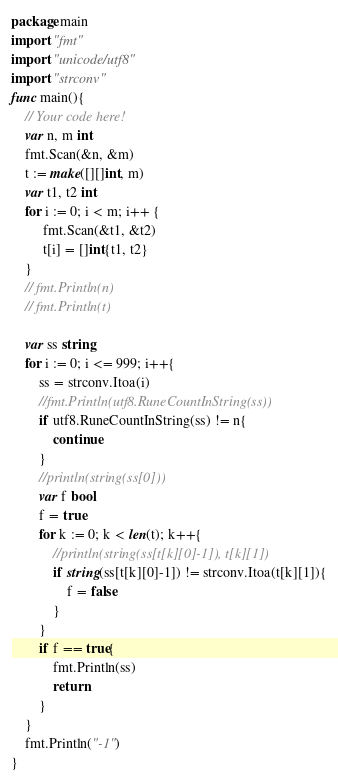Convert code to text. <code><loc_0><loc_0><loc_500><loc_500><_Go_>package main
import "fmt"
import "unicode/utf8"
import "strconv"
func main(){
    // Your code here!
    var n, m int
    fmt.Scan(&n, &m)
    t := make([][]int, m)
    var t1, t2 int
    for i := 0; i < m; i++ {
         fmt.Scan(&t1, &t2)
         t[i] = []int{t1, t2}
    }
    // fmt.Println(n)
    // fmt.Println(t)
    
    var ss string
    for i := 0; i <= 999; i++{
        ss = strconv.Itoa(i)
        //fmt.Println(utf8.RuneCountInString(ss))
        if utf8.RuneCountInString(ss) != n{
            continue
        }
        //println(string(ss[0]))
        var f bool
        f = true
        for k := 0; k < len(t); k++{
            //println(string(ss[t[k][0]-1]), t[k][1])
            if string(ss[t[k][0]-1]) != strconv.Itoa(t[k][1]){
                f = false
            }
        }
        if f == true{
            fmt.Println(ss)
            return
        }
    }
    fmt.Println("-1")
}
</code> 